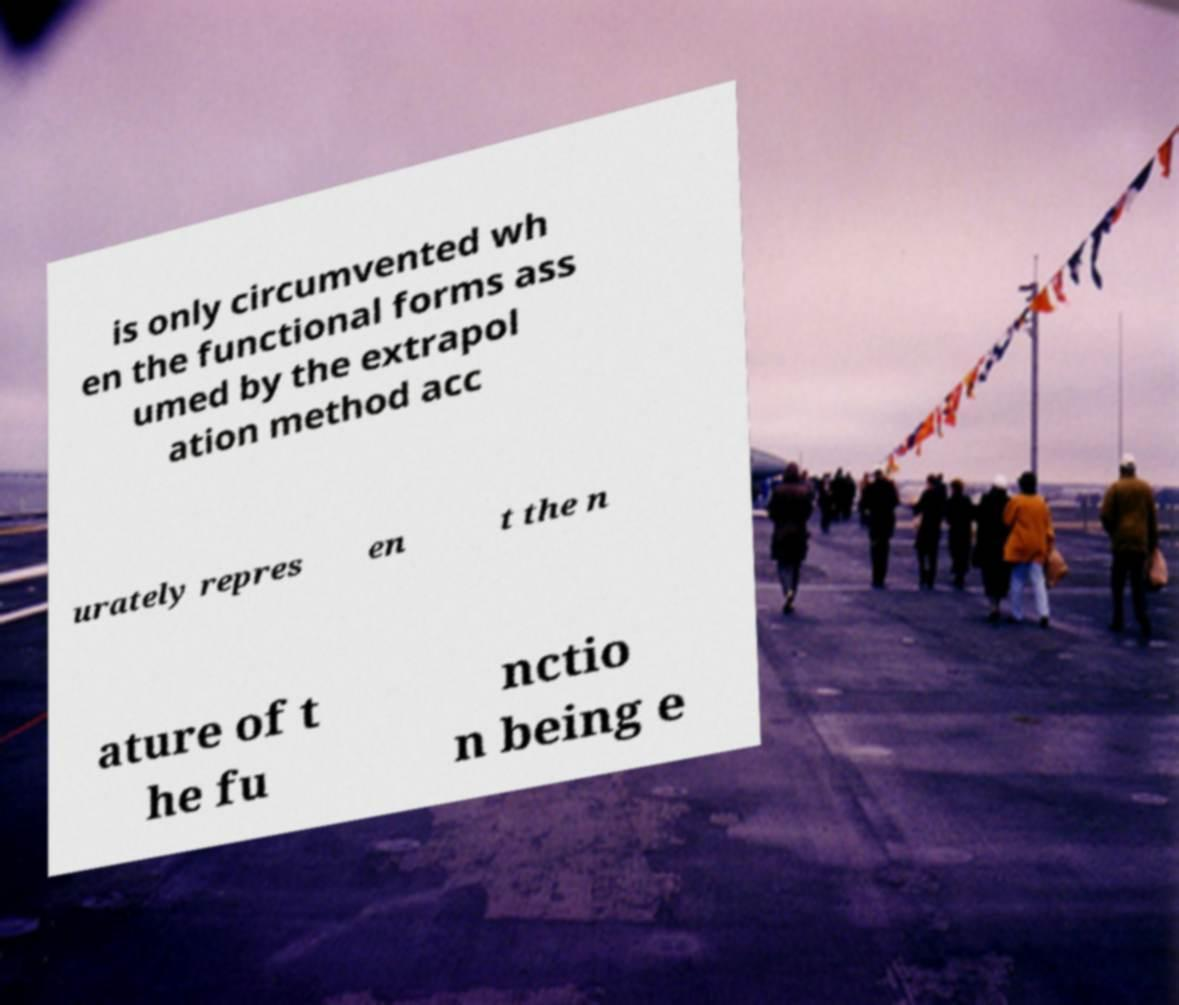Can you read and provide the text displayed in the image?This photo seems to have some interesting text. Can you extract and type it out for me? is only circumvented wh en the functional forms ass umed by the extrapol ation method acc urately repres en t the n ature of t he fu nctio n being e 